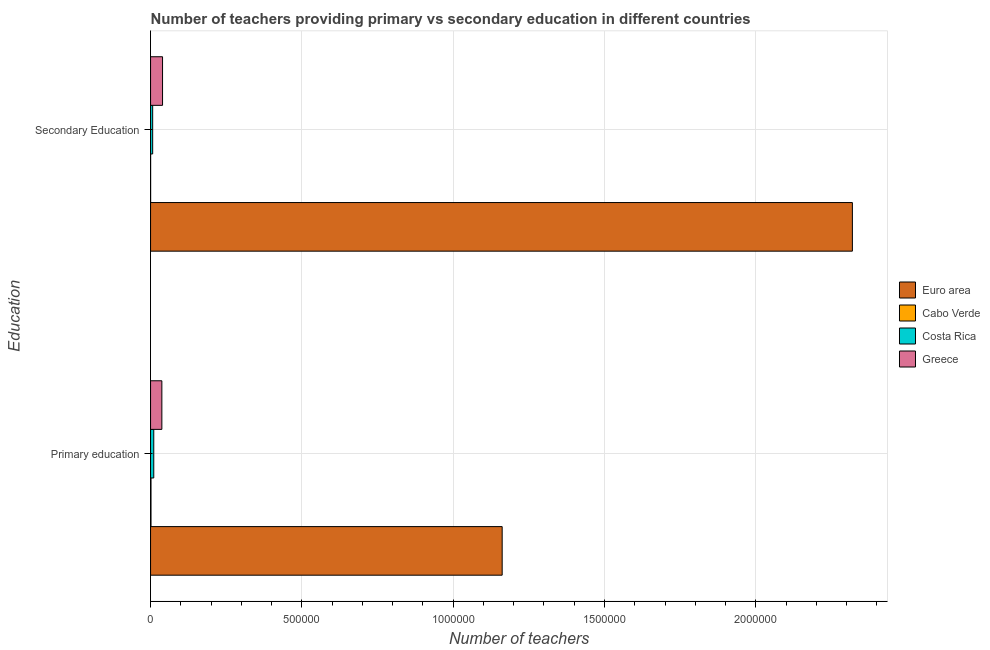Are the number of bars per tick equal to the number of legend labels?
Offer a terse response. Yes. How many bars are there on the 1st tick from the top?
Offer a very short reply. 4. What is the label of the 1st group of bars from the top?
Your response must be concise. Secondary Education. What is the number of primary teachers in Cabo Verde?
Offer a terse response. 1436. Across all countries, what is the maximum number of secondary teachers?
Ensure brevity in your answer.  2.32e+06. Across all countries, what is the minimum number of secondary teachers?
Make the answer very short. 184. In which country was the number of secondary teachers maximum?
Ensure brevity in your answer.  Euro area. In which country was the number of secondary teachers minimum?
Give a very brief answer. Cabo Verde. What is the total number of primary teachers in the graph?
Your answer should be very brief. 1.21e+06. What is the difference between the number of primary teachers in Greece and that in Cabo Verde?
Provide a short and direct response. 3.59e+04. What is the difference between the number of secondary teachers in Greece and the number of primary teachers in Cabo Verde?
Offer a very short reply. 3.81e+04. What is the average number of secondary teachers per country?
Your response must be concise. 5.91e+05. What is the difference between the number of secondary teachers and number of primary teachers in Euro area?
Your answer should be very brief. 1.16e+06. In how many countries, is the number of secondary teachers greater than 900000 ?
Your answer should be very brief. 1. What is the ratio of the number of secondary teachers in Costa Rica to that in Euro area?
Your response must be concise. 0. What does the 3rd bar from the top in Primary education represents?
Ensure brevity in your answer.  Cabo Verde. What does the 2nd bar from the bottom in Primary education represents?
Your answer should be compact. Cabo Verde. How many countries are there in the graph?
Your response must be concise. 4. What is the difference between two consecutive major ticks on the X-axis?
Ensure brevity in your answer.  5.00e+05. Are the values on the major ticks of X-axis written in scientific E-notation?
Provide a succinct answer. No. Does the graph contain any zero values?
Offer a terse response. No. Where does the legend appear in the graph?
Your answer should be compact. Center right. How many legend labels are there?
Ensure brevity in your answer.  4. What is the title of the graph?
Provide a succinct answer. Number of teachers providing primary vs secondary education in different countries. Does "Central Europe" appear as one of the legend labels in the graph?
Keep it short and to the point. No. What is the label or title of the X-axis?
Offer a terse response. Number of teachers. What is the label or title of the Y-axis?
Offer a very short reply. Education. What is the Number of teachers in Euro area in Primary education?
Your response must be concise. 1.16e+06. What is the Number of teachers of Cabo Verde in Primary education?
Your answer should be very brief. 1436. What is the Number of teachers in Costa Rica in Primary education?
Provide a succinct answer. 1.06e+04. What is the Number of teachers of Greece in Primary education?
Give a very brief answer. 3.73e+04. What is the Number of teachers of Euro area in Secondary Education?
Your response must be concise. 2.32e+06. What is the Number of teachers in Cabo Verde in Secondary Education?
Provide a succinct answer. 184. What is the Number of teachers of Costa Rica in Secondary Education?
Your answer should be compact. 6955. What is the Number of teachers of Greece in Secondary Education?
Provide a short and direct response. 3.96e+04. Across all Education, what is the maximum Number of teachers in Euro area?
Provide a succinct answer. 2.32e+06. Across all Education, what is the maximum Number of teachers in Cabo Verde?
Your response must be concise. 1436. Across all Education, what is the maximum Number of teachers in Costa Rica?
Provide a short and direct response. 1.06e+04. Across all Education, what is the maximum Number of teachers in Greece?
Ensure brevity in your answer.  3.96e+04. Across all Education, what is the minimum Number of teachers of Euro area?
Offer a very short reply. 1.16e+06. Across all Education, what is the minimum Number of teachers in Cabo Verde?
Ensure brevity in your answer.  184. Across all Education, what is the minimum Number of teachers in Costa Rica?
Provide a short and direct response. 6955. Across all Education, what is the minimum Number of teachers of Greece?
Offer a very short reply. 3.73e+04. What is the total Number of teachers of Euro area in the graph?
Offer a very short reply. 3.48e+06. What is the total Number of teachers in Cabo Verde in the graph?
Make the answer very short. 1620. What is the total Number of teachers in Costa Rica in the graph?
Provide a short and direct response. 1.75e+04. What is the total Number of teachers in Greece in the graph?
Your answer should be very brief. 7.69e+04. What is the difference between the Number of teachers in Euro area in Primary education and that in Secondary Education?
Your response must be concise. -1.16e+06. What is the difference between the Number of teachers in Cabo Verde in Primary education and that in Secondary Education?
Keep it short and to the point. 1252. What is the difference between the Number of teachers of Costa Rica in Primary education and that in Secondary Education?
Your answer should be very brief. 3601. What is the difference between the Number of teachers of Greece in Primary education and that in Secondary Education?
Give a very brief answer. -2256. What is the difference between the Number of teachers in Euro area in Primary education and the Number of teachers in Cabo Verde in Secondary Education?
Give a very brief answer. 1.16e+06. What is the difference between the Number of teachers in Euro area in Primary education and the Number of teachers in Costa Rica in Secondary Education?
Your answer should be very brief. 1.15e+06. What is the difference between the Number of teachers in Euro area in Primary education and the Number of teachers in Greece in Secondary Education?
Your answer should be compact. 1.12e+06. What is the difference between the Number of teachers in Cabo Verde in Primary education and the Number of teachers in Costa Rica in Secondary Education?
Ensure brevity in your answer.  -5519. What is the difference between the Number of teachers of Cabo Verde in Primary education and the Number of teachers of Greece in Secondary Education?
Keep it short and to the point. -3.81e+04. What is the difference between the Number of teachers in Costa Rica in Primary education and the Number of teachers in Greece in Secondary Education?
Your answer should be compact. -2.90e+04. What is the average Number of teachers in Euro area per Education?
Offer a very short reply. 1.74e+06. What is the average Number of teachers in Cabo Verde per Education?
Make the answer very short. 810. What is the average Number of teachers in Costa Rica per Education?
Offer a very short reply. 8755.5. What is the average Number of teachers of Greece per Education?
Your answer should be very brief. 3.84e+04. What is the difference between the Number of teachers in Euro area and Number of teachers in Cabo Verde in Primary education?
Your answer should be compact. 1.16e+06. What is the difference between the Number of teachers of Euro area and Number of teachers of Costa Rica in Primary education?
Ensure brevity in your answer.  1.15e+06. What is the difference between the Number of teachers in Euro area and Number of teachers in Greece in Primary education?
Your response must be concise. 1.12e+06. What is the difference between the Number of teachers in Cabo Verde and Number of teachers in Costa Rica in Primary education?
Make the answer very short. -9120. What is the difference between the Number of teachers in Cabo Verde and Number of teachers in Greece in Primary education?
Your answer should be very brief. -3.59e+04. What is the difference between the Number of teachers of Costa Rica and Number of teachers of Greece in Primary education?
Your answer should be very brief. -2.68e+04. What is the difference between the Number of teachers of Euro area and Number of teachers of Cabo Verde in Secondary Education?
Your response must be concise. 2.32e+06. What is the difference between the Number of teachers in Euro area and Number of teachers in Costa Rica in Secondary Education?
Give a very brief answer. 2.31e+06. What is the difference between the Number of teachers of Euro area and Number of teachers of Greece in Secondary Education?
Make the answer very short. 2.28e+06. What is the difference between the Number of teachers of Cabo Verde and Number of teachers of Costa Rica in Secondary Education?
Your answer should be very brief. -6771. What is the difference between the Number of teachers of Cabo Verde and Number of teachers of Greece in Secondary Education?
Make the answer very short. -3.94e+04. What is the difference between the Number of teachers of Costa Rica and Number of teachers of Greece in Secondary Education?
Your answer should be compact. -3.26e+04. What is the ratio of the Number of teachers of Euro area in Primary education to that in Secondary Education?
Ensure brevity in your answer.  0.5. What is the ratio of the Number of teachers of Cabo Verde in Primary education to that in Secondary Education?
Provide a succinct answer. 7.8. What is the ratio of the Number of teachers in Costa Rica in Primary education to that in Secondary Education?
Give a very brief answer. 1.52. What is the ratio of the Number of teachers in Greece in Primary education to that in Secondary Education?
Give a very brief answer. 0.94. What is the difference between the highest and the second highest Number of teachers of Euro area?
Offer a very short reply. 1.16e+06. What is the difference between the highest and the second highest Number of teachers of Cabo Verde?
Keep it short and to the point. 1252. What is the difference between the highest and the second highest Number of teachers of Costa Rica?
Your answer should be very brief. 3601. What is the difference between the highest and the second highest Number of teachers in Greece?
Keep it short and to the point. 2256. What is the difference between the highest and the lowest Number of teachers of Euro area?
Your response must be concise. 1.16e+06. What is the difference between the highest and the lowest Number of teachers in Cabo Verde?
Give a very brief answer. 1252. What is the difference between the highest and the lowest Number of teachers in Costa Rica?
Your answer should be compact. 3601. What is the difference between the highest and the lowest Number of teachers of Greece?
Offer a very short reply. 2256. 